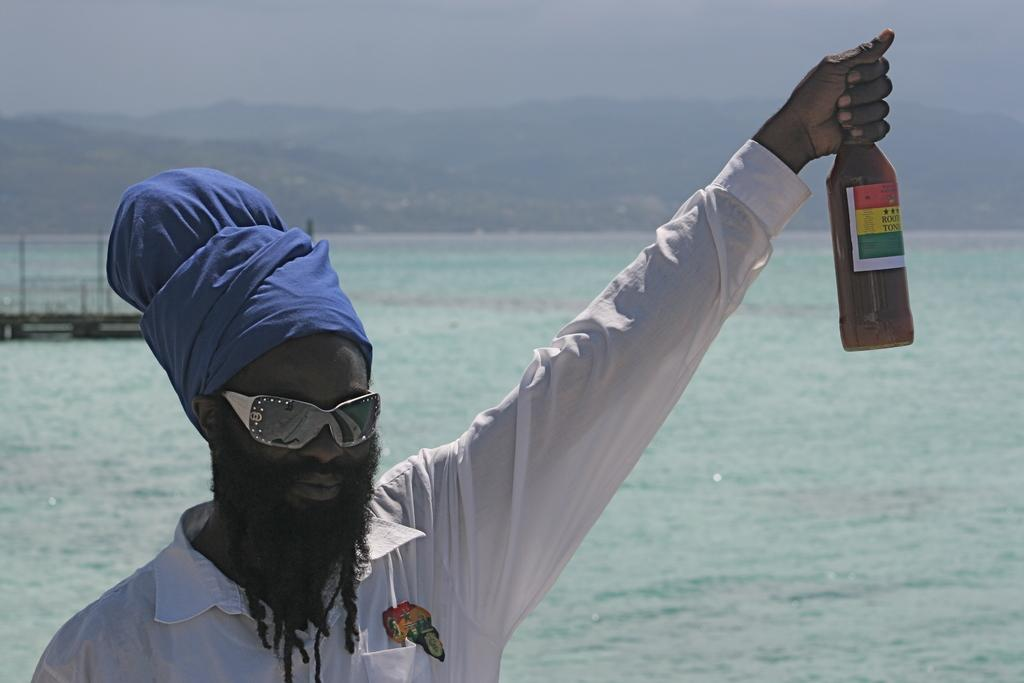What is the man in the image holding? The man is holding a bottle. Can you describe the background of the image? There is water visible in the background of the image. Is the man in the image tying a knot with his hat? There is no hat present in the image, and the man is not tying a knot. 